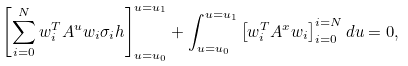<formula> <loc_0><loc_0><loc_500><loc_500>\left [ \sum _ { i = 0 } ^ { N } w _ { i } ^ { T } A ^ { u } w _ { i } \sigma _ { i } h \right ] _ { u = u _ { 0 } } ^ { u = u _ { 1 } } + \int _ { u = u _ { 0 } } ^ { u = u _ { 1 } } \left [ w _ { i } ^ { T } A ^ { x } w _ { i } \right ] _ { i = 0 } ^ { i = N } d u = 0 ,</formula> 